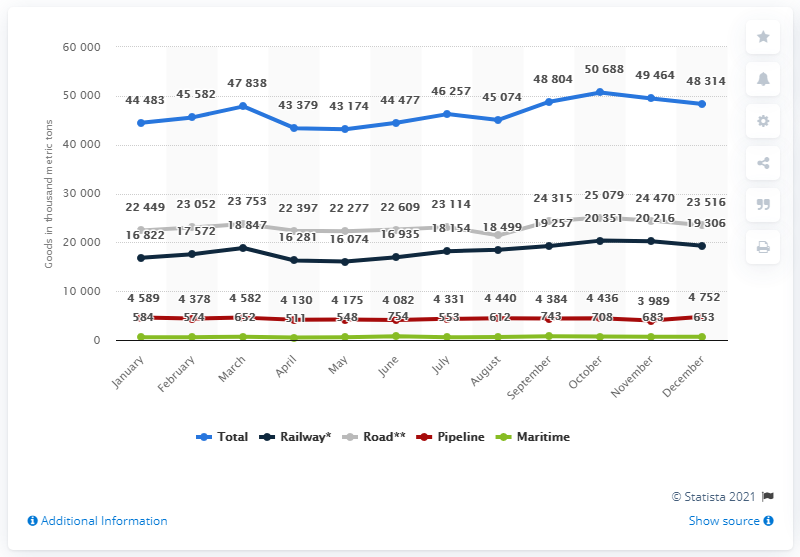Highlight a few significant elements in this photo. The total number of goods from January to March is 137,903. The peak in the total number of goods was reached in October. 